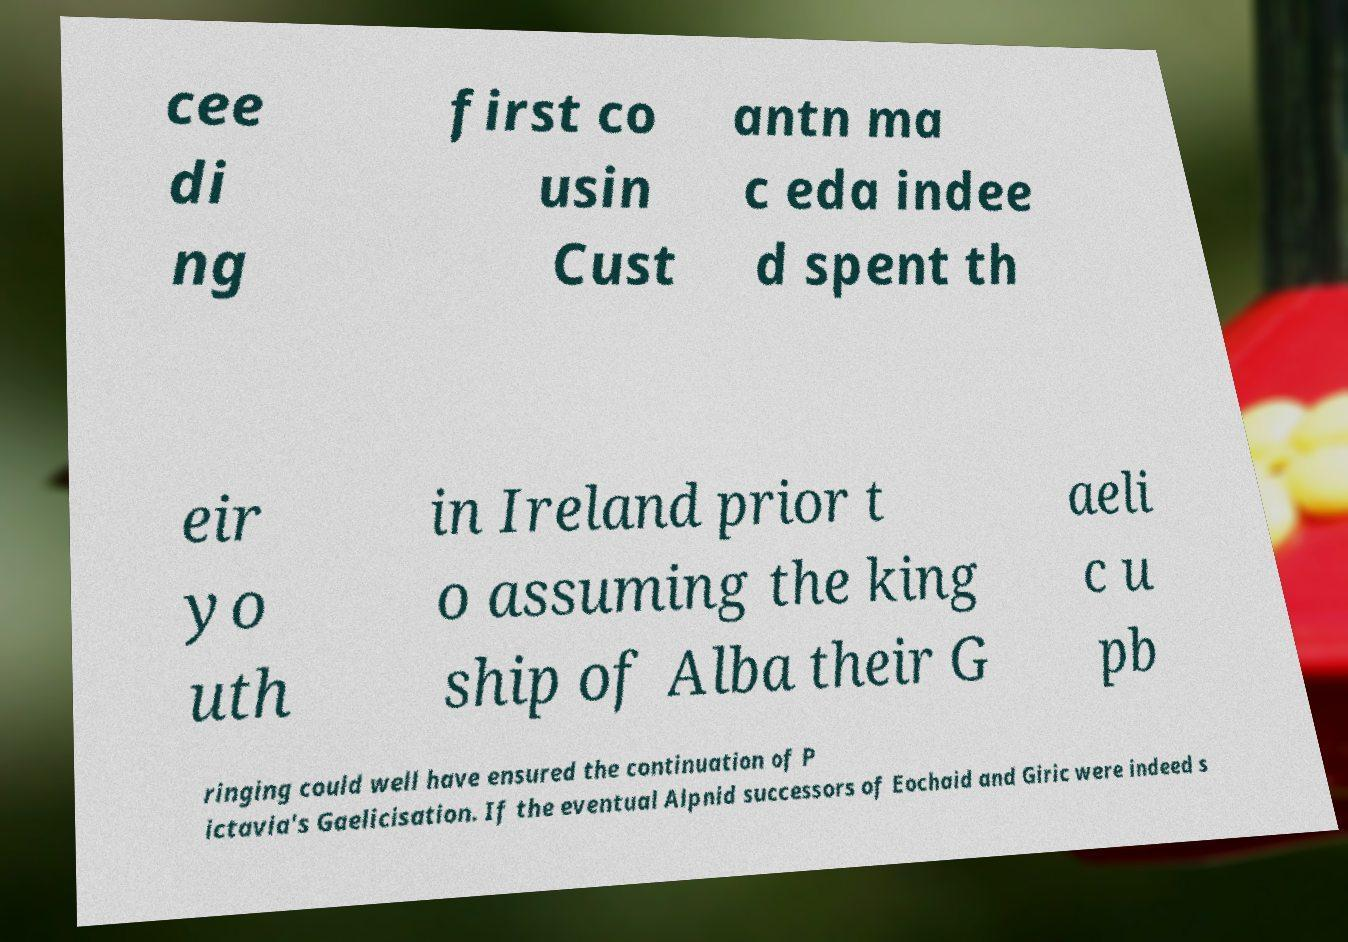I need the written content from this picture converted into text. Can you do that? cee di ng first co usin Cust antn ma c eda indee d spent th eir yo uth in Ireland prior t o assuming the king ship of Alba their G aeli c u pb ringing could well have ensured the continuation of P ictavia's Gaelicisation. If the eventual Alpnid successors of Eochaid and Giric were indeed s 